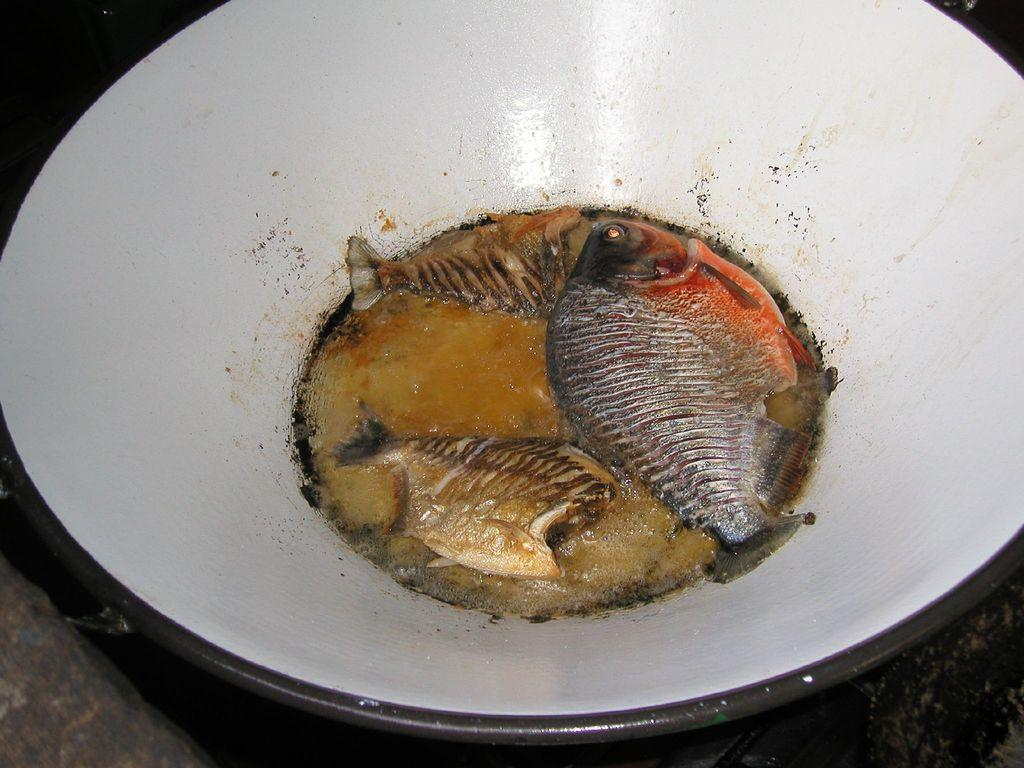What type of animals are in the image? There are fishes in the image. Where are the fishes located? The fishes are in a bowl. On what surface is the bowl placed? The bowl is placed on a table. How many hands are visible in the image? There are no hands visible in the image; it only features fishes in a bowl placed on a table. 